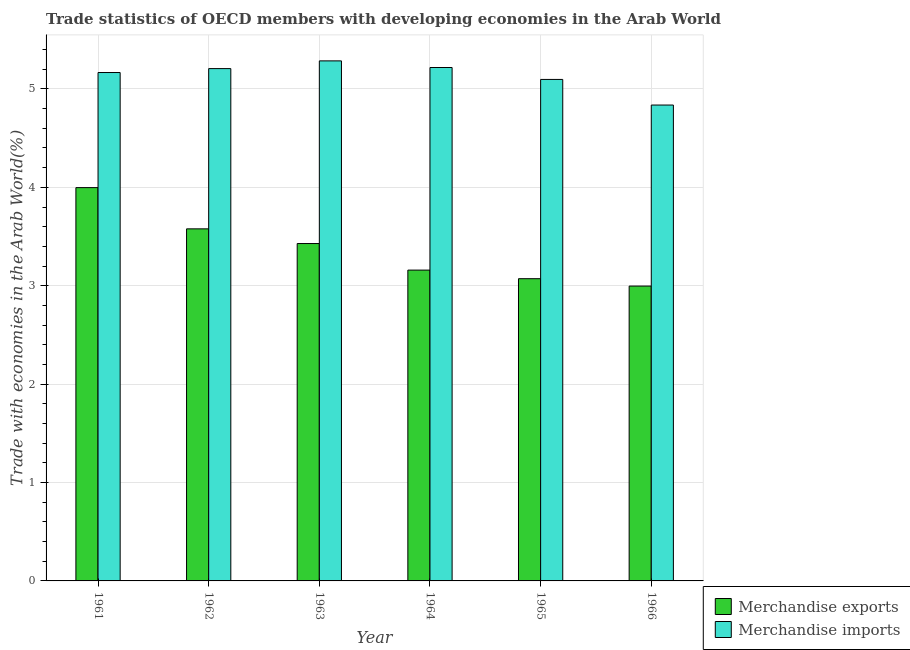How many different coloured bars are there?
Ensure brevity in your answer.  2. Are the number of bars per tick equal to the number of legend labels?
Provide a succinct answer. Yes. Are the number of bars on each tick of the X-axis equal?
Make the answer very short. Yes. How many bars are there on the 4th tick from the left?
Make the answer very short. 2. What is the label of the 6th group of bars from the left?
Your response must be concise. 1966. In how many cases, is the number of bars for a given year not equal to the number of legend labels?
Your answer should be very brief. 0. What is the merchandise exports in 1962?
Offer a terse response. 3.58. Across all years, what is the maximum merchandise exports?
Provide a short and direct response. 4. Across all years, what is the minimum merchandise imports?
Your response must be concise. 4.84. In which year was the merchandise imports minimum?
Your answer should be very brief. 1966. What is the total merchandise exports in the graph?
Make the answer very short. 20.23. What is the difference between the merchandise exports in 1965 and that in 1966?
Your response must be concise. 0.08. What is the difference between the merchandise exports in 1965 and the merchandise imports in 1962?
Keep it short and to the point. -0.51. What is the average merchandise imports per year?
Make the answer very short. 5.13. In how many years, is the merchandise imports greater than 3.2 %?
Give a very brief answer. 6. What is the ratio of the merchandise exports in 1962 to that in 1965?
Offer a very short reply. 1.16. Is the difference between the merchandise exports in 1961 and 1965 greater than the difference between the merchandise imports in 1961 and 1965?
Ensure brevity in your answer.  No. What is the difference between the highest and the second highest merchandise imports?
Your response must be concise. 0.07. What is the difference between the highest and the lowest merchandise imports?
Offer a terse response. 0.45. In how many years, is the merchandise imports greater than the average merchandise imports taken over all years?
Your answer should be compact. 4. What does the 1st bar from the left in 1966 represents?
Give a very brief answer. Merchandise exports. Are the values on the major ticks of Y-axis written in scientific E-notation?
Your answer should be very brief. No. Does the graph contain any zero values?
Ensure brevity in your answer.  No. Does the graph contain grids?
Provide a short and direct response. Yes. How many legend labels are there?
Keep it short and to the point. 2. What is the title of the graph?
Your answer should be very brief. Trade statistics of OECD members with developing economies in the Arab World. What is the label or title of the X-axis?
Keep it short and to the point. Year. What is the label or title of the Y-axis?
Offer a very short reply. Trade with economies in the Arab World(%). What is the Trade with economies in the Arab World(%) in Merchandise exports in 1961?
Keep it short and to the point. 4. What is the Trade with economies in the Arab World(%) of Merchandise imports in 1961?
Offer a very short reply. 5.17. What is the Trade with economies in the Arab World(%) in Merchandise exports in 1962?
Ensure brevity in your answer.  3.58. What is the Trade with economies in the Arab World(%) of Merchandise imports in 1962?
Your answer should be very brief. 5.21. What is the Trade with economies in the Arab World(%) of Merchandise exports in 1963?
Give a very brief answer. 3.43. What is the Trade with economies in the Arab World(%) of Merchandise imports in 1963?
Your answer should be compact. 5.29. What is the Trade with economies in the Arab World(%) of Merchandise exports in 1964?
Offer a very short reply. 3.16. What is the Trade with economies in the Arab World(%) of Merchandise imports in 1964?
Make the answer very short. 5.22. What is the Trade with economies in the Arab World(%) in Merchandise exports in 1965?
Give a very brief answer. 3.07. What is the Trade with economies in the Arab World(%) in Merchandise imports in 1965?
Ensure brevity in your answer.  5.1. What is the Trade with economies in the Arab World(%) in Merchandise exports in 1966?
Make the answer very short. 3. What is the Trade with economies in the Arab World(%) in Merchandise imports in 1966?
Provide a succinct answer. 4.84. Across all years, what is the maximum Trade with economies in the Arab World(%) in Merchandise exports?
Offer a very short reply. 4. Across all years, what is the maximum Trade with economies in the Arab World(%) of Merchandise imports?
Your answer should be compact. 5.29. Across all years, what is the minimum Trade with economies in the Arab World(%) of Merchandise exports?
Provide a short and direct response. 3. Across all years, what is the minimum Trade with economies in the Arab World(%) in Merchandise imports?
Give a very brief answer. 4.84. What is the total Trade with economies in the Arab World(%) of Merchandise exports in the graph?
Offer a very short reply. 20.23. What is the total Trade with economies in the Arab World(%) of Merchandise imports in the graph?
Offer a very short reply. 30.81. What is the difference between the Trade with economies in the Arab World(%) in Merchandise exports in 1961 and that in 1962?
Your answer should be compact. 0.42. What is the difference between the Trade with economies in the Arab World(%) in Merchandise imports in 1961 and that in 1962?
Ensure brevity in your answer.  -0.04. What is the difference between the Trade with economies in the Arab World(%) in Merchandise exports in 1961 and that in 1963?
Ensure brevity in your answer.  0.57. What is the difference between the Trade with economies in the Arab World(%) of Merchandise imports in 1961 and that in 1963?
Provide a succinct answer. -0.12. What is the difference between the Trade with economies in the Arab World(%) of Merchandise exports in 1961 and that in 1964?
Provide a short and direct response. 0.84. What is the difference between the Trade with economies in the Arab World(%) of Merchandise imports in 1961 and that in 1964?
Your response must be concise. -0.05. What is the difference between the Trade with economies in the Arab World(%) in Merchandise exports in 1961 and that in 1965?
Make the answer very short. 0.93. What is the difference between the Trade with economies in the Arab World(%) in Merchandise imports in 1961 and that in 1965?
Make the answer very short. 0.07. What is the difference between the Trade with economies in the Arab World(%) in Merchandise imports in 1961 and that in 1966?
Make the answer very short. 0.33. What is the difference between the Trade with economies in the Arab World(%) in Merchandise exports in 1962 and that in 1963?
Offer a very short reply. 0.15. What is the difference between the Trade with economies in the Arab World(%) of Merchandise imports in 1962 and that in 1963?
Provide a succinct answer. -0.08. What is the difference between the Trade with economies in the Arab World(%) of Merchandise exports in 1962 and that in 1964?
Your answer should be very brief. 0.42. What is the difference between the Trade with economies in the Arab World(%) in Merchandise imports in 1962 and that in 1964?
Provide a succinct answer. -0.01. What is the difference between the Trade with economies in the Arab World(%) in Merchandise exports in 1962 and that in 1965?
Offer a terse response. 0.51. What is the difference between the Trade with economies in the Arab World(%) of Merchandise imports in 1962 and that in 1965?
Ensure brevity in your answer.  0.11. What is the difference between the Trade with economies in the Arab World(%) in Merchandise exports in 1962 and that in 1966?
Provide a succinct answer. 0.58. What is the difference between the Trade with economies in the Arab World(%) in Merchandise imports in 1962 and that in 1966?
Keep it short and to the point. 0.37. What is the difference between the Trade with economies in the Arab World(%) in Merchandise exports in 1963 and that in 1964?
Give a very brief answer. 0.27. What is the difference between the Trade with economies in the Arab World(%) of Merchandise imports in 1963 and that in 1964?
Your response must be concise. 0.07. What is the difference between the Trade with economies in the Arab World(%) of Merchandise exports in 1963 and that in 1965?
Your answer should be compact. 0.36. What is the difference between the Trade with economies in the Arab World(%) in Merchandise imports in 1963 and that in 1965?
Offer a terse response. 0.19. What is the difference between the Trade with economies in the Arab World(%) in Merchandise exports in 1963 and that in 1966?
Your response must be concise. 0.43. What is the difference between the Trade with economies in the Arab World(%) in Merchandise imports in 1963 and that in 1966?
Keep it short and to the point. 0.45. What is the difference between the Trade with economies in the Arab World(%) in Merchandise exports in 1964 and that in 1965?
Your response must be concise. 0.09. What is the difference between the Trade with economies in the Arab World(%) of Merchandise imports in 1964 and that in 1965?
Your response must be concise. 0.12. What is the difference between the Trade with economies in the Arab World(%) in Merchandise exports in 1964 and that in 1966?
Ensure brevity in your answer.  0.16. What is the difference between the Trade with economies in the Arab World(%) in Merchandise imports in 1964 and that in 1966?
Keep it short and to the point. 0.38. What is the difference between the Trade with economies in the Arab World(%) of Merchandise exports in 1965 and that in 1966?
Ensure brevity in your answer.  0.08. What is the difference between the Trade with economies in the Arab World(%) in Merchandise imports in 1965 and that in 1966?
Keep it short and to the point. 0.26. What is the difference between the Trade with economies in the Arab World(%) in Merchandise exports in 1961 and the Trade with economies in the Arab World(%) in Merchandise imports in 1962?
Provide a succinct answer. -1.21. What is the difference between the Trade with economies in the Arab World(%) in Merchandise exports in 1961 and the Trade with economies in the Arab World(%) in Merchandise imports in 1963?
Give a very brief answer. -1.29. What is the difference between the Trade with economies in the Arab World(%) of Merchandise exports in 1961 and the Trade with economies in the Arab World(%) of Merchandise imports in 1964?
Your answer should be compact. -1.22. What is the difference between the Trade with economies in the Arab World(%) of Merchandise exports in 1961 and the Trade with economies in the Arab World(%) of Merchandise imports in 1965?
Your response must be concise. -1.1. What is the difference between the Trade with economies in the Arab World(%) in Merchandise exports in 1961 and the Trade with economies in the Arab World(%) in Merchandise imports in 1966?
Offer a terse response. -0.84. What is the difference between the Trade with economies in the Arab World(%) in Merchandise exports in 1962 and the Trade with economies in the Arab World(%) in Merchandise imports in 1963?
Offer a very short reply. -1.71. What is the difference between the Trade with economies in the Arab World(%) of Merchandise exports in 1962 and the Trade with economies in the Arab World(%) of Merchandise imports in 1964?
Your answer should be compact. -1.64. What is the difference between the Trade with economies in the Arab World(%) in Merchandise exports in 1962 and the Trade with economies in the Arab World(%) in Merchandise imports in 1965?
Your response must be concise. -1.52. What is the difference between the Trade with economies in the Arab World(%) in Merchandise exports in 1962 and the Trade with economies in the Arab World(%) in Merchandise imports in 1966?
Offer a very short reply. -1.26. What is the difference between the Trade with economies in the Arab World(%) of Merchandise exports in 1963 and the Trade with economies in the Arab World(%) of Merchandise imports in 1964?
Keep it short and to the point. -1.79. What is the difference between the Trade with economies in the Arab World(%) of Merchandise exports in 1963 and the Trade with economies in the Arab World(%) of Merchandise imports in 1965?
Keep it short and to the point. -1.67. What is the difference between the Trade with economies in the Arab World(%) in Merchandise exports in 1963 and the Trade with economies in the Arab World(%) in Merchandise imports in 1966?
Provide a succinct answer. -1.41. What is the difference between the Trade with economies in the Arab World(%) in Merchandise exports in 1964 and the Trade with economies in the Arab World(%) in Merchandise imports in 1965?
Provide a short and direct response. -1.94. What is the difference between the Trade with economies in the Arab World(%) in Merchandise exports in 1964 and the Trade with economies in the Arab World(%) in Merchandise imports in 1966?
Ensure brevity in your answer.  -1.68. What is the difference between the Trade with economies in the Arab World(%) of Merchandise exports in 1965 and the Trade with economies in the Arab World(%) of Merchandise imports in 1966?
Offer a terse response. -1.76. What is the average Trade with economies in the Arab World(%) of Merchandise exports per year?
Offer a very short reply. 3.37. What is the average Trade with economies in the Arab World(%) in Merchandise imports per year?
Keep it short and to the point. 5.13. In the year 1961, what is the difference between the Trade with economies in the Arab World(%) of Merchandise exports and Trade with economies in the Arab World(%) of Merchandise imports?
Offer a terse response. -1.17. In the year 1962, what is the difference between the Trade with economies in the Arab World(%) in Merchandise exports and Trade with economies in the Arab World(%) in Merchandise imports?
Your answer should be compact. -1.63. In the year 1963, what is the difference between the Trade with economies in the Arab World(%) in Merchandise exports and Trade with economies in the Arab World(%) in Merchandise imports?
Provide a short and direct response. -1.86. In the year 1964, what is the difference between the Trade with economies in the Arab World(%) of Merchandise exports and Trade with economies in the Arab World(%) of Merchandise imports?
Provide a succinct answer. -2.06. In the year 1965, what is the difference between the Trade with economies in the Arab World(%) in Merchandise exports and Trade with economies in the Arab World(%) in Merchandise imports?
Offer a terse response. -2.02. In the year 1966, what is the difference between the Trade with economies in the Arab World(%) in Merchandise exports and Trade with economies in the Arab World(%) in Merchandise imports?
Your answer should be very brief. -1.84. What is the ratio of the Trade with economies in the Arab World(%) of Merchandise exports in 1961 to that in 1962?
Provide a succinct answer. 1.12. What is the ratio of the Trade with economies in the Arab World(%) of Merchandise exports in 1961 to that in 1963?
Your answer should be compact. 1.17. What is the ratio of the Trade with economies in the Arab World(%) of Merchandise imports in 1961 to that in 1963?
Keep it short and to the point. 0.98. What is the ratio of the Trade with economies in the Arab World(%) in Merchandise exports in 1961 to that in 1964?
Offer a very short reply. 1.27. What is the ratio of the Trade with economies in the Arab World(%) of Merchandise imports in 1961 to that in 1964?
Your answer should be very brief. 0.99. What is the ratio of the Trade with economies in the Arab World(%) in Merchandise exports in 1961 to that in 1965?
Ensure brevity in your answer.  1.3. What is the ratio of the Trade with economies in the Arab World(%) in Merchandise imports in 1961 to that in 1965?
Make the answer very short. 1.01. What is the ratio of the Trade with economies in the Arab World(%) of Merchandise exports in 1961 to that in 1966?
Offer a very short reply. 1.33. What is the ratio of the Trade with economies in the Arab World(%) of Merchandise imports in 1961 to that in 1966?
Offer a terse response. 1.07. What is the ratio of the Trade with economies in the Arab World(%) of Merchandise exports in 1962 to that in 1963?
Ensure brevity in your answer.  1.04. What is the ratio of the Trade with economies in the Arab World(%) of Merchandise imports in 1962 to that in 1963?
Provide a succinct answer. 0.99. What is the ratio of the Trade with economies in the Arab World(%) of Merchandise exports in 1962 to that in 1964?
Keep it short and to the point. 1.13. What is the ratio of the Trade with economies in the Arab World(%) in Merchandise imports in 1962 to that in 1964?
Your answer should be compact. 1. What is the ratio of the Trade with economies in the Arab World(%) in Merchandise exports in 1962 to that in 1965?
Make the answer very short. 1.16. What is the ratio of the Trade with economies in the Arab World(%) in Merchandise imports in 1962 to that in 1965?
Give a very brief answer. 1.02. What is the ratio of the Trade with economies in the Arab World(%) in Merchandise exports in 1962 to that in 1966?
Keep it short and to the point. 1.19. What is the ratio of the Trade with economies in the Arab World(%) in Merchandise imports in 1962 to that in 1966?
Keep it short and to the point. 1.08. What is the ratio of the Trade with economies in the Arab World(%) of Merchandise exports in 1963 to that in 1964?
Offer a terse response. 1.09. What is the ratio of the Trade with economies in the Arab World(%) in Merchandise imports in 1963 to that in 1964?
Keep it short and to the point. 1.01. What is the ratio of the Trade with economies in the Arab World(%) of Merchandise exports in 1963 to that in 1965?
Your answer should be compact. 1.12. What is the ratio of the Trade with economies in the Arab World(%) of Merchandise exports in 1963 to that in 1966?
Keep it short and to the point. 1.14. What is the ratio of the Trade with economies in the Arab World(%) in Merchandise imports in 1963 to that in 1966?
Make the answer very short. 1.09. What is the ratio of the Trade with economies in the Arab World(%) of Merchandise exports in 1964 to that in 1965?
Offer a very short reply. 1.03. What is the ratio of the Trade with economies in the Arab World(%) of Merchandise imports in 1964 to that in 1965?
Your response must be concise. 1.02. What is the ratio of the Trade with economies in the Arab World(%) in Merchandise exports in 1964 to that in 1966?
Keep it short and to the point. 1.05. What is the ratio of the Trade with economies in the Arab World(%) of Merchandise imports in 1964 to that in 1966?
Offer a terse response. 1.08. What is the ratio of the Trade with economies in the Arab World(%) in Merchandise exports in 1965 to that in 1966?
Your answer should be compact. 1.03. What is the ratio of the Trade with economies in the Arab World(%) in Merchandise imports in 1965 to that in 1966?
Your response must be concise. 1.05. What is the difference between the highest and the second highest Trade with economies in the Arab World(%) of Merchandise exports?
Your answer should be compact. 0.42. What is the difference between the highest and the second highest Trade with economies in the Arab World(%) of Merchandise imports?
Keep it short and to the point. 0.07. What is the difference between the highest and the lowest Trade with economies in the Arab World(%) in Merchandise exports?
Provide a succinct answer. 1. What is the difference between the highest and the lowest Trade with economies in the Arab World(%) of Merchandise imports?
Provide a succinct answer. 0.45. 